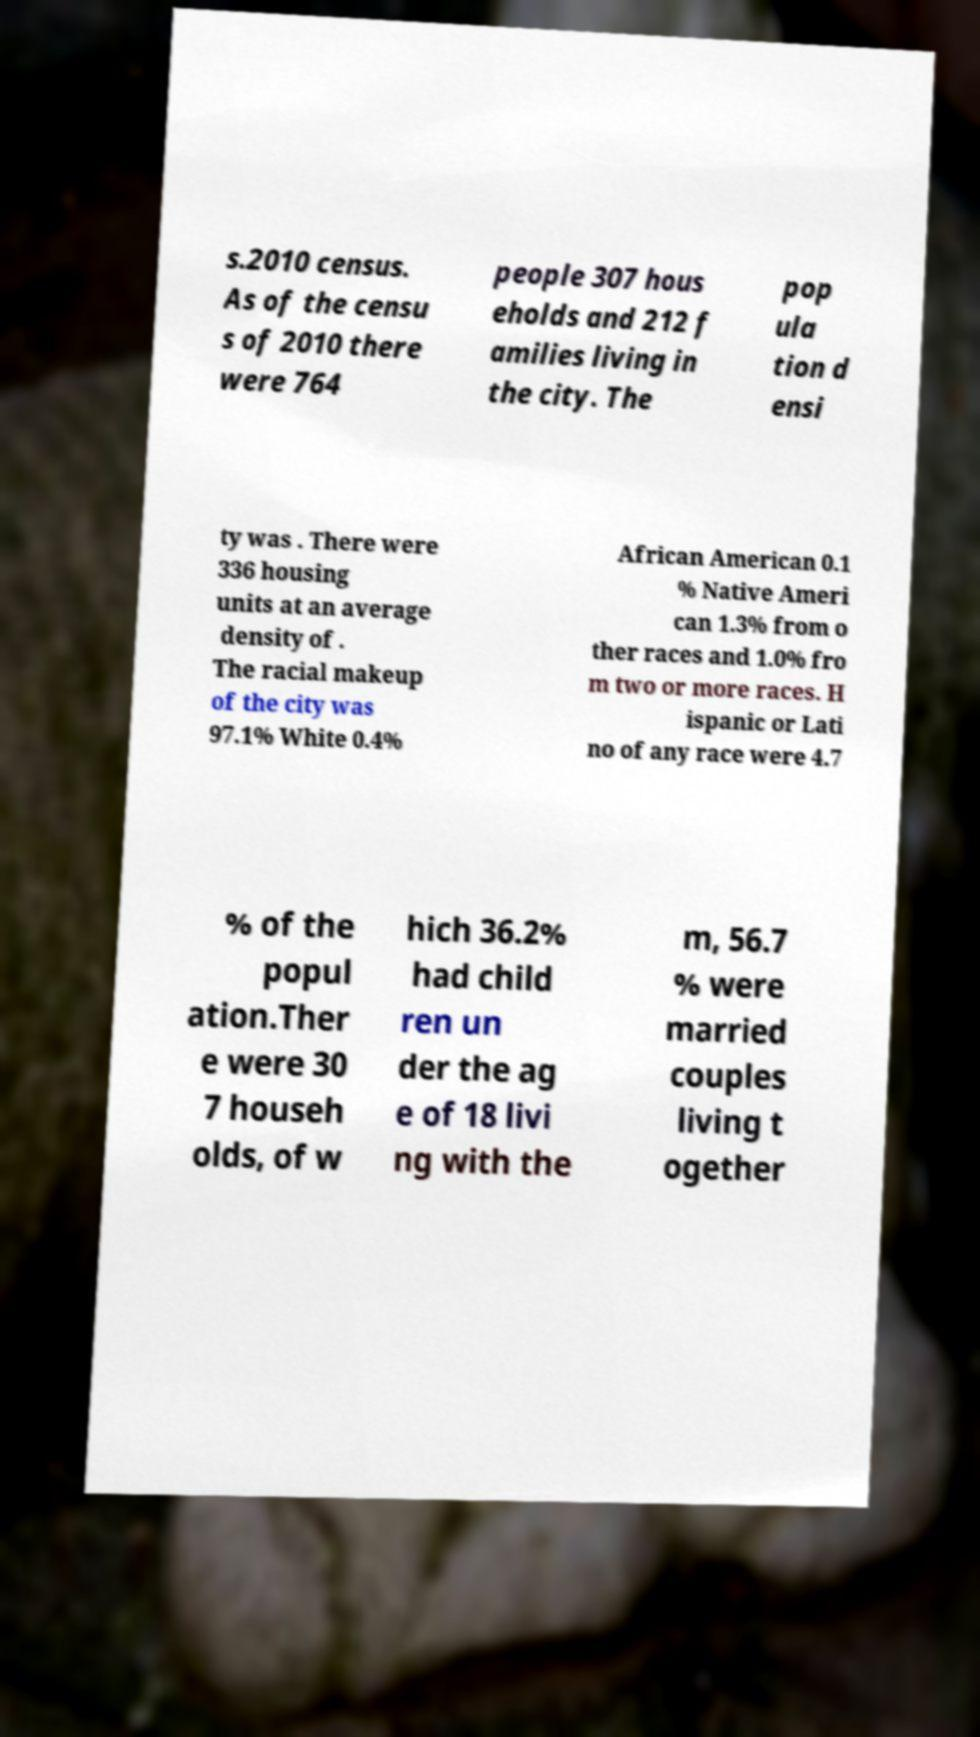Please identify and transcribe the text found in this image. s.2010 census. As of the censu s of 2010 there were 764 people 307 hous eholds and 212 f amilies living in the city. The pop ula tion d ensi ty was . There were 336 housing units at an average density of . The racial makeup of the city was 97.1% White 0.4% African American 0.1 % Native Ameri can 1.3% from o ther races and 1.0% fro m two or more races. H ispanic or Lati no of any race were 4.7 % of the popul ation.Ther e were 30 7 househ olds, of w hich 36.2% had child ren un der the ag e of 18 livi ng with the m, 56.7 % were married couples living t ogether 